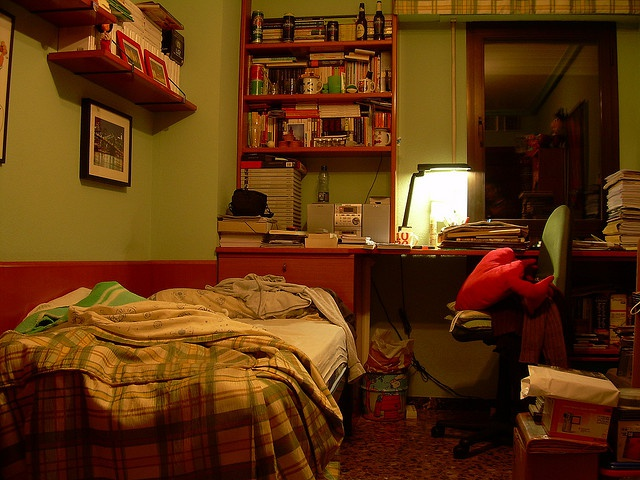Describe the objects in this image and their specific colors. I can see bed in black, olive, orange, and maroon tones, chair in black, olive, and maroon tones, book in black, maroon, brown, and olive tones, book in black, maroon, and brown tones, and book in black, olive, and maroon tones in this image. 